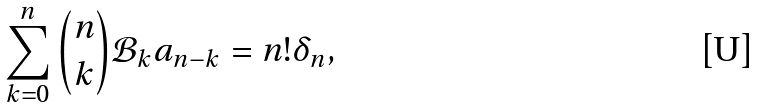Convert formula to latex. <formula><loc_0><loc_0><loc_500><loc_500>\sum _ { k = 0 } ^ { n } \binom { n } { k } \mathcal { B } _ { k } a _ { n - k } = n ! \delta _ { n } ,</formula> 